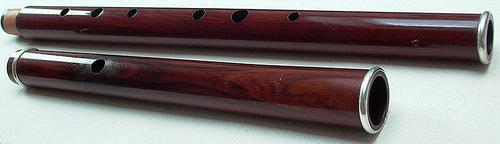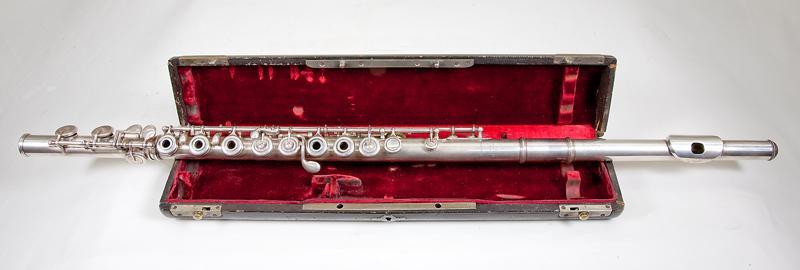The first image is the image on the left, the second image is the image on the right. Evaluate the accuracy of this statement regarding the images: "Each image shows instruments in or with a case.". Is it true? Answer yes or no. No. The first image is the image on the left, the second image is the image on the right. Assess this claim about the two images: "Each image includes an open case for an instrument, and in at least one image, an instrument is fully inside the case.". Correct or not? Answer yes or no. No. 